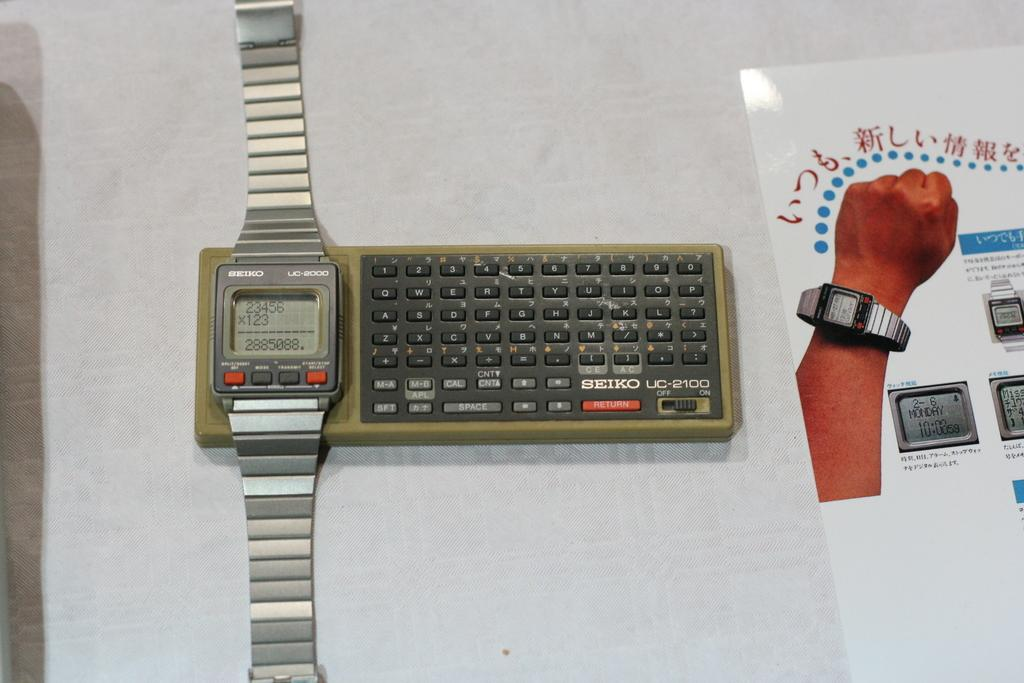<image>
Describe the image concisely. A Seiko UC-2000 watch is on a Seiko keyboard and next to a flyer. 